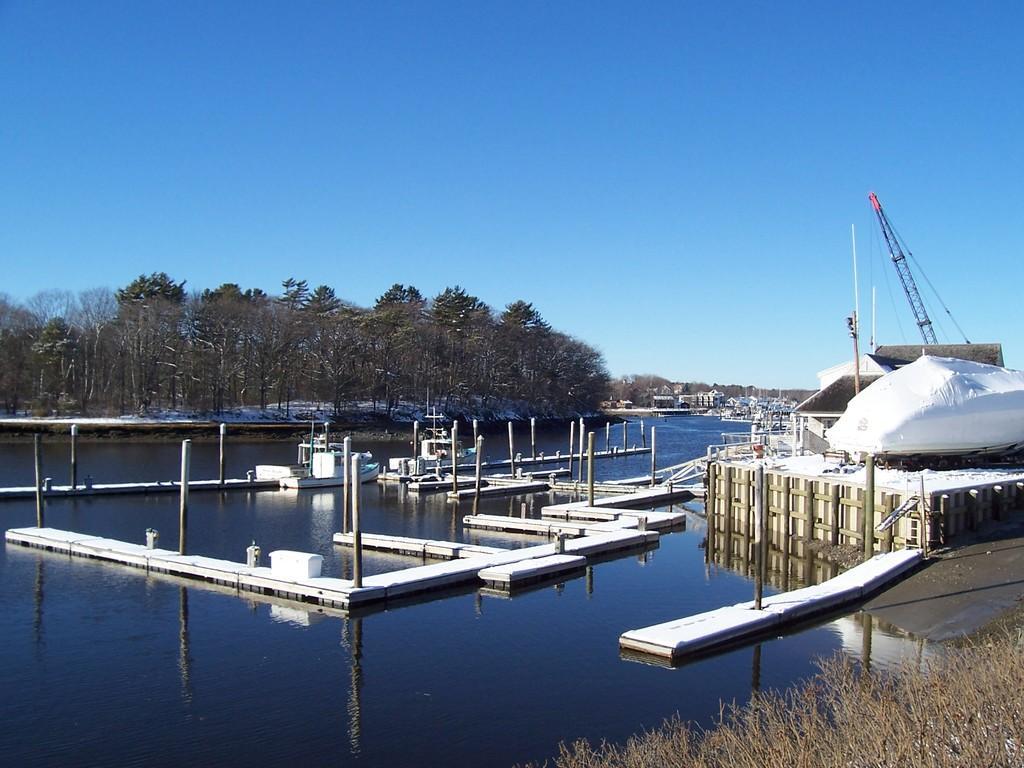How would you summarize this image in a sentence or two? In this image I can see poles, fence, grass, crane and boats in the water. In the background I can see trees and houses. At the top I can see the blue sky. This image is taken may be near the lake. 